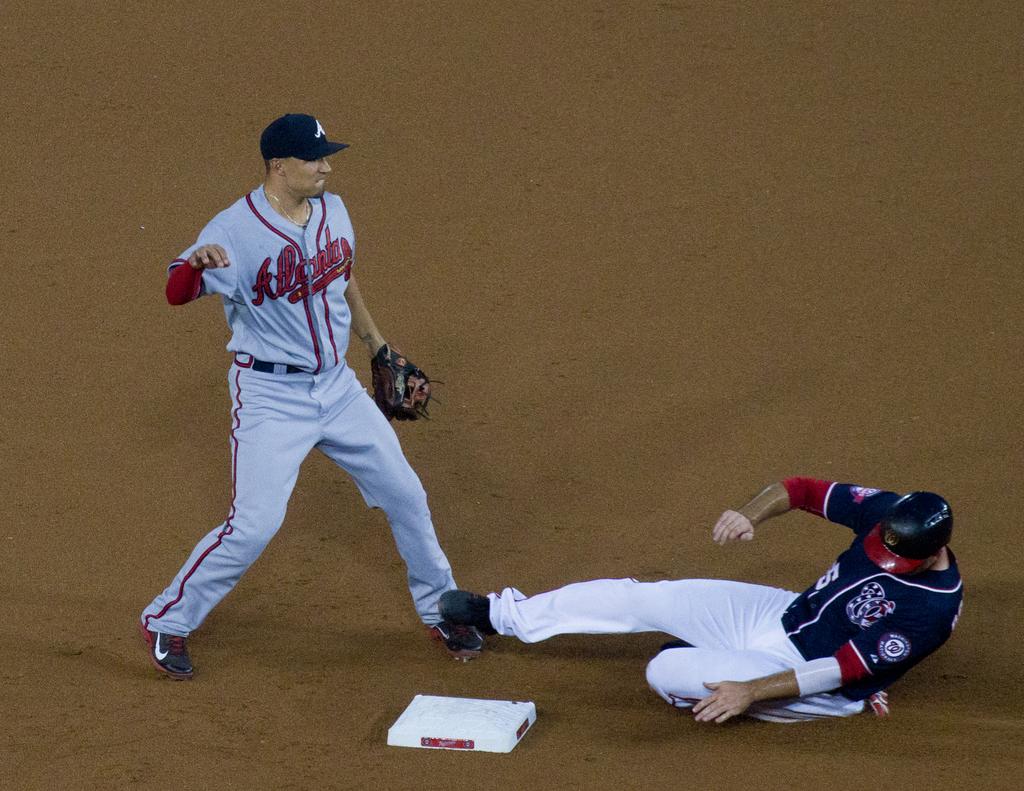What team does he play for?
Keep it short and to the point. Atlanta. 